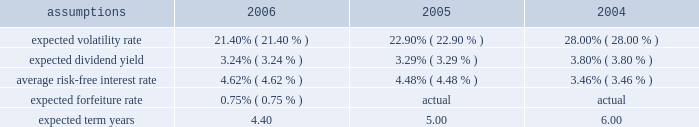Eastman notes to the audited consolidated financial statements stock option awards option awards are granted to non-employee directors on an annual basis and to employees who meet certain eligibility requirements .
A single annual option grant is usually awarded to eligible employees in the fourth quarter of each year , if and when granted by the compensation and management development committee of the board of directors , and occasional individual grants are awarded to eligible employees throughout the year .
Option awards have an exercise price equal to the closing price of the company's stock on the date of grant .
The term of options is ten years with vesting periods that vary up to three years .
Vesting usually occurs ratably or at the end of the vesting period .
Sfas no .
123 ( r ) requires that stock option awards be valued at fair value determined by market price , if actively traded in a public market or , if not , calculated using an option pricing financial model .
The fair value of the company's options cannot be determined by market value as they are not traded in an open market .
Accordingly , a financial pricing model is utilized to determine fair value .
The company utilizes the black scholes merton ( "bsm" ) model which relies on certain assumptions to estimate an option's fair value .
The weighted average assumptions used in the determination of fair value for stock options awarded in 2006 , 2005 and 2004 are provided in the table below: .
Prior to adoption of sfas no .
123 ( r ) , the company calculated the expected term of stock options of six years .
Effective with the fourth quarter 2005 annual option award , the company analyzed historical annual grant transactions over a ten year period comprising exercises , post-vesting cancellations and expirations to determine the expected term .
The company expects to execute this analysis each year preceding the annual option grant to ensure that all assumptions based upon internal data reflect the most reasonable expectations for fair value determination .
The weighted average expected term of 4.4 years for 2006 reflects the impact of this annual analysis and the weighting of option swap and reload grants which may have much shorter expected terms than new option grants .
The volatility rate of grants is derived from historical company common stock volatility over the same time period as the expected term .
The company uses a weekly high closing stock price based upon daily closing prices in the week .
The volatility rate is derived by mathematical formula utilizing the weekly high closing price data .
For the periods presented above , the expected dividend yield is derived by mathematical formula which uses the expected company annual dividend amount over the expected term divided by the fair market value of the company's common stock at the grant date .
The average risk-free interest rate is derived from united states department of treasury published interest rates of daily yield curves for the same time period as the expected term .
Prior to adoption of sfas no .
123 ( r ) , the company did not estimate forfeitures and recognized them as they occurred for proforma disclosure of share-based compensation expense .
With adoption of sfas no .
123 ( r ) , estimated forfeitures must be considered in recording share-based compensation expense .
Estimated forfeiture rates vary with each type of award affected by several factors , one of which is the varying composition and characteristics of the award participants .
Estimated forfeitures for the company's share-based awards historically range from 0.75 percent to 10.0 percent with the estimated forfeitures for options at 0.75 percent. .
What is the percent change in expected dividend yield between 2005 and 2006? 
Computations: ((3.24 - 3.29) / 3.29)
Answer: -0.0152. 